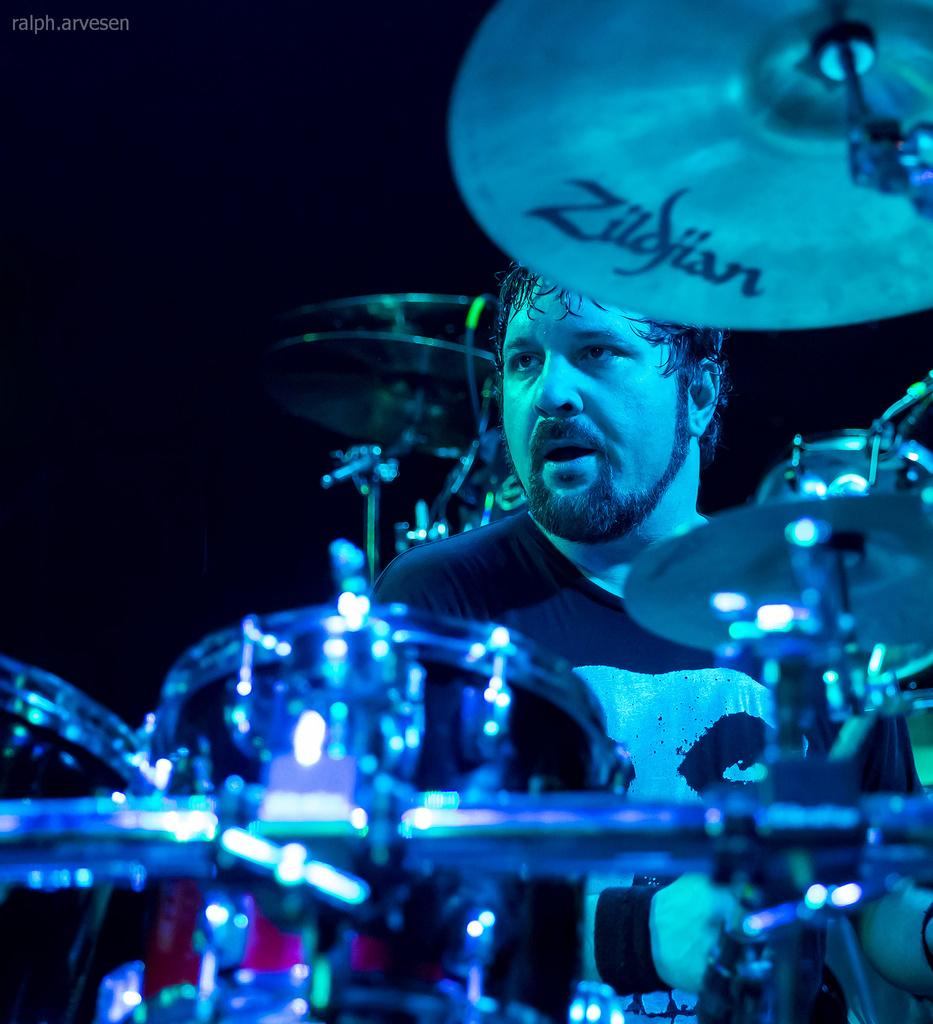What is the man in the image doing? The man is sitting in the image. What else can be seen in the image besides the man? Musical instruments are present in the image. How would you describe the background of the image? The background of the image is dark. Where is the text located in the image? The text is visible in the top left side of the image. How many horses are present in the image? There are no horses present in the image. What type of organization is depicted in the image? There is no organization depicted in the image; it features a man sitting and musical instruments. 